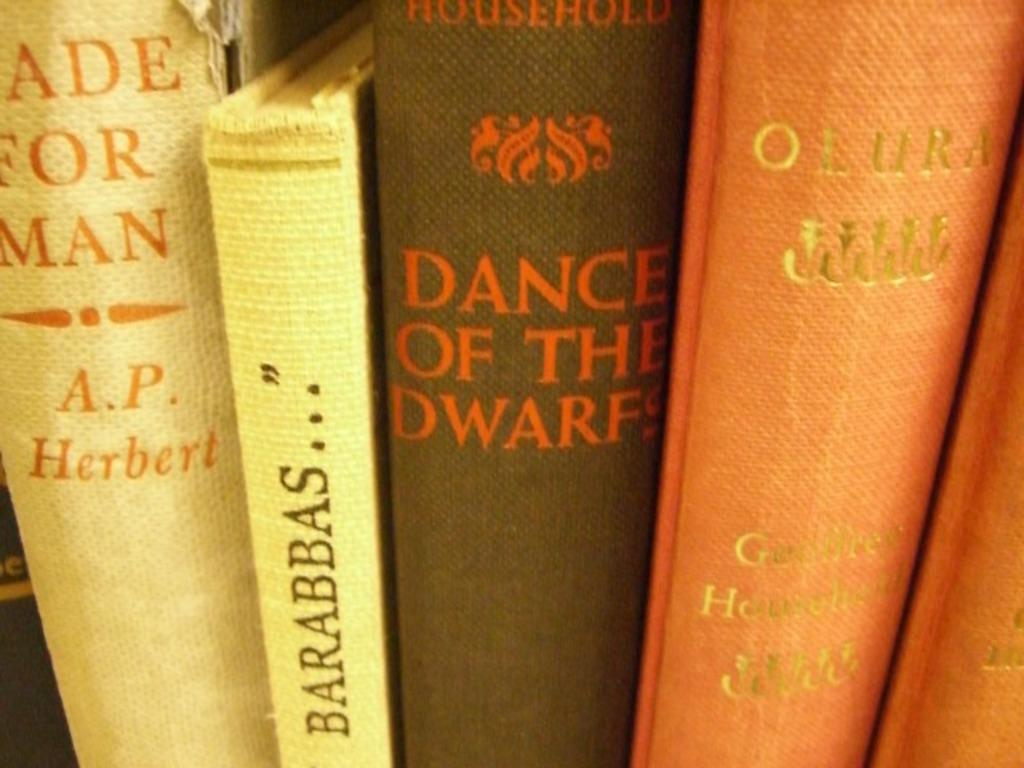<image>
Relay a brief, clear account of the picture shown. Dance of the Dwarfs sit in between four other books 